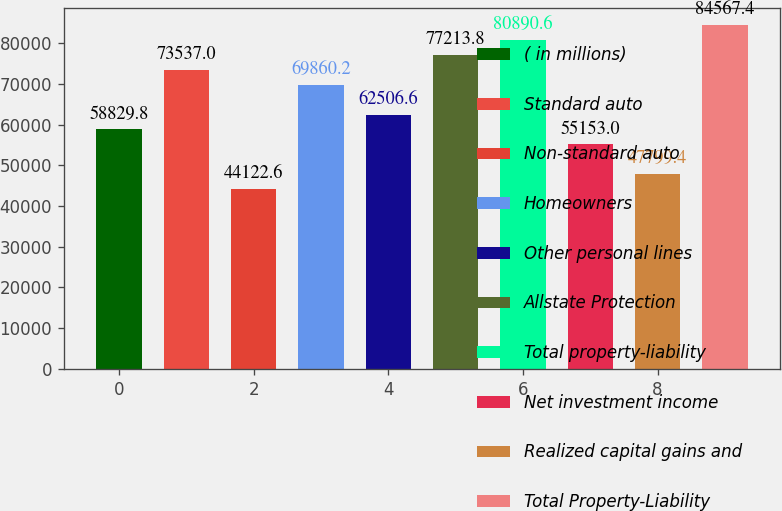<chart> <loc_0><loc_0><loc_500><loc_500><bar_chart><fcel>( in millions)<fcel>Standard auto<fcel>Non-standard auto<fcel>Homeowners<fcel>Other personal lines<fcel>Allstate Protection<fcel>Total property-liability<fcel>Net investment income<fcel>Realized capital gains and<fcel>Total Property-Liability<nl><fcel>58829.8<fcel>73537<fcel>44122.6<fcel>69860.2<fcel>62506.6<fcel>77213.8<fcel>80890.6<fcel>55153<fcel>47799.4<fcel>84567.4<nl></chart> 